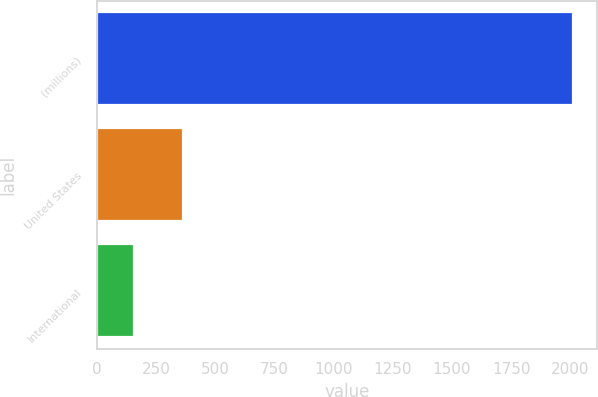<chart> <loc_0><loc_0><loc_500><loc_500><bar_chart><fcel>(millions)<fcel>United States<fcel>International<nl><fcel>2012<fcel>366.2<fcel>159.9<nl></chart> 